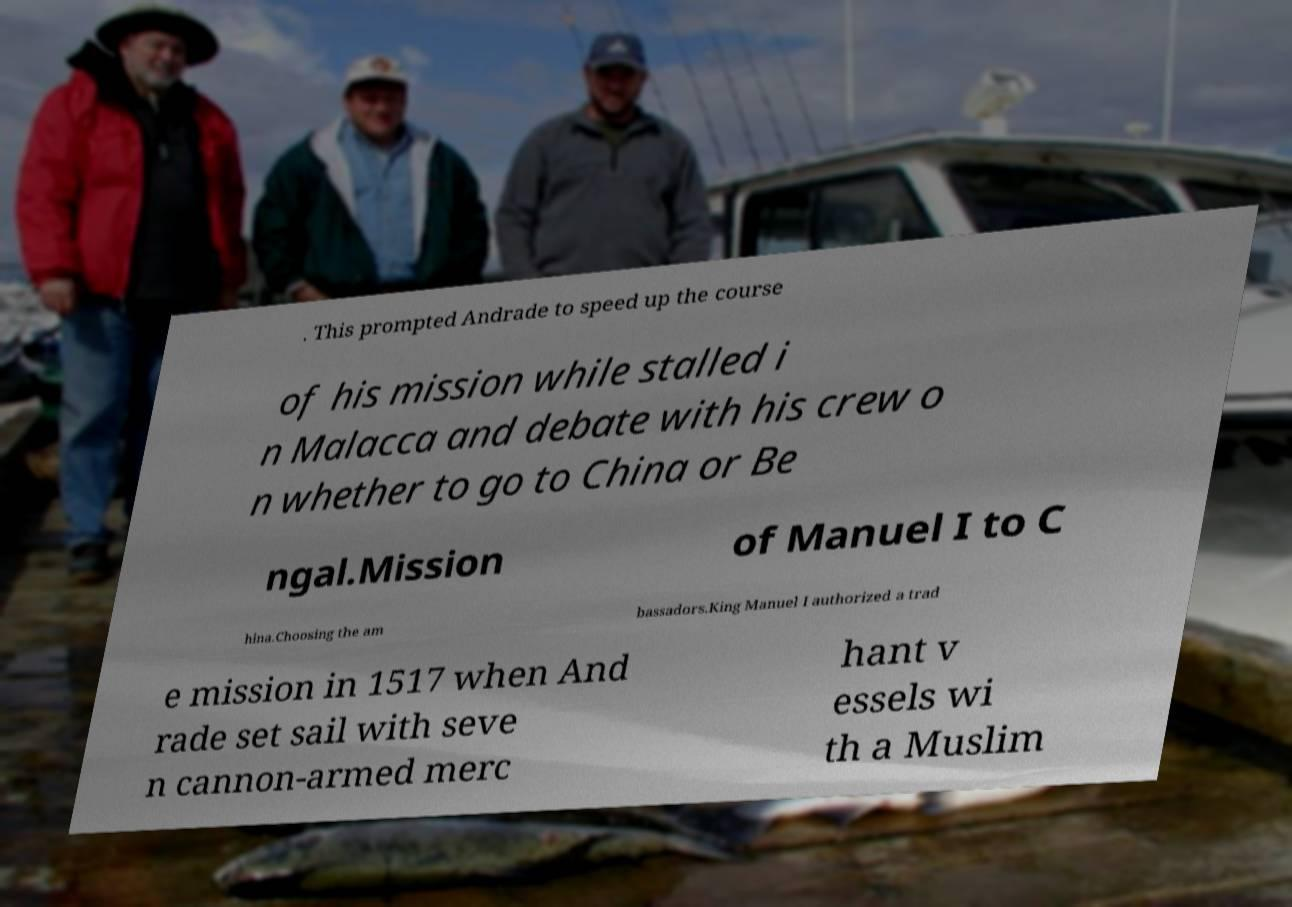Please read and relay the text visible in this image. What does it say? . This prompted Andrade to speed up the course of his mission while stalled i n Malacca and debate with his crew o n whether to go to China or Be ngal.Mission of Manuel I to C hina.Choosing the am bassadors.King Manuel I authorized a trad e mission in 1517 when And rade set sail with seve n cannon-armed merc hant v essels wi th a Muslim 